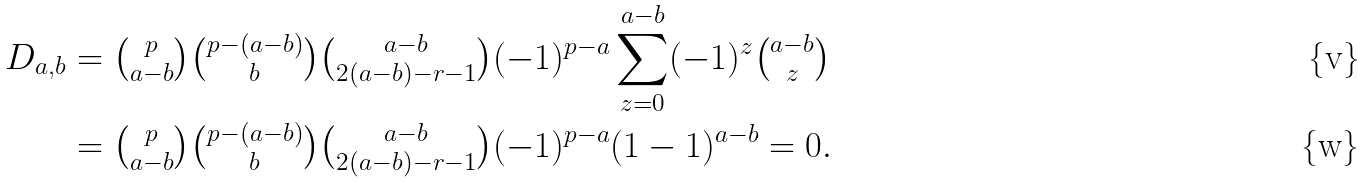Convert formula to latex. <formula><loc_0><loc_0><loc_500><loc_500>D _ { a , b } & = \tbinom p { a - b } \tbinom { p - ( a - b ) } { b } \tbinom { a - b } { 2 ( a - b ) - r - 1 } ( - 1 ) ^ { p - a } \sum _ { z = 0 } ^ { a - b } ( - 1 ) ^ { z } \tbinom { a - b } { z } \\ & = \tbinom p { a - b } \tbinom { p - ( a - b ) } { b } \tbinom { a - b } { 2 ( a - b ) - r - 1 } ( - 1 ) ^ { p - a } ( 1 - 1 ) ^ { a - b } = 0 .</formula> 